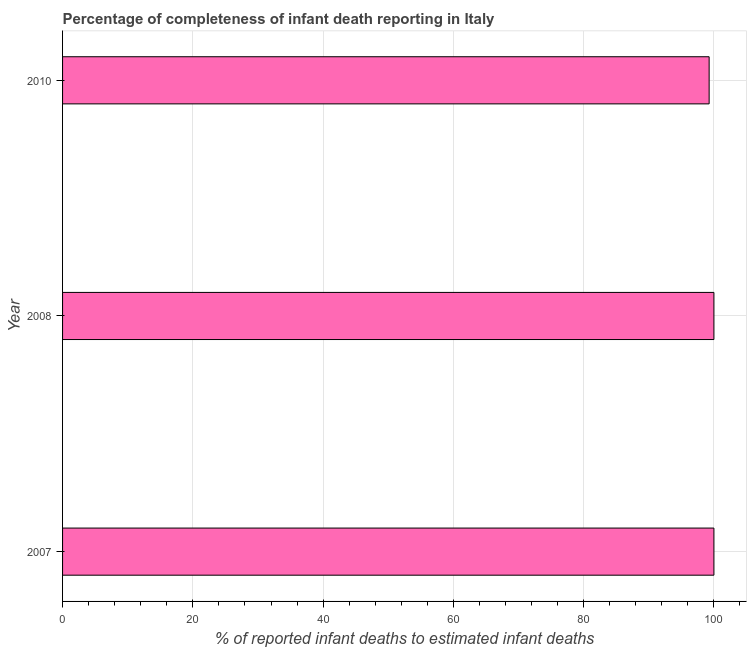What is the title of the graph?
Your answer should be compact. Percentage of completeness of infant death reporting in Italy. What is the label or title of the X-axis?
Keep it short and to the point. % of reported infant deaths to estimated infant deaths. What is the label or title of the Y-axis?
Offer a very short reply. Year. What is the completeness of infant death reporting in 2007?
Offer a terse response. 100. Across all years, what is the minimum completeness of infant death reporting?
Your answer should be compact. 99.27. What is the sum of the completeness of infant death reporting?
Offer a very short reply. 299.27. What is the difference between the completeness of infant death reporting in 2007 and 2010?
Make the answer very short. 0.73. What is the average completeness of infant death reporting per year?
Offer a terse response. 99.75. In how many years, is the completeness of infant death reporting greater than 48 %?
Keep it short and to the point. 3. Do a majority of the years between 2008 and 2010 (inclusive) have completeness of infant death reporting greater than 24 %?
Keep it short and to the point. Yes. What is the ratio of the completeness of infant death reporting in 2007 to that in 2010?
Your answer should be compact. 1.01. Is the difference between the completeness of infant death reporting in 2007 and 2008 greater than the difference between any two years?
Your response must be concise. No. What is the difference between the highest and the second highest completeness of infant death reporting?
Offer a terse response. 0. Is the sum of the completeness of infant death reporting in 2007 and 2008 greater than the maximum completeness of infant death reporting across all years?
Offer a terse response. Yes. What is the difference between the highest and the lowest completeness of infant death reporting?
Your response must be concise. 0.73. In how many years, is the completeness of infant death reporting greater than the average completeness of infant death reporting taken over all years?
Your answer should be very brief. 2. Are all the bars in the graph horizontal?
Give a very brief answer. Yes. What is the % of reported infant deaths to estimated infant deaths in 2008?
Ensure brevity in your answer.  100. What is the % of reported infant deaths to estimated infant deaths in 2010?
Keep it short and to the point. 99.27. What is the difference between the % of reported infant deaths to estimated infant deaths in 2007 and 2010?
Ensure brevity in your answer.  0.73. What is the difference between the % of reported infant deaths to estimated infant deaths in 2008 and 2010?
Your answer should be compact. 0.73. What is the ratio of the % of reported infant deaths to estimated infant deaths in 2007 to that in 2008?
Your response must be concise. 1. 